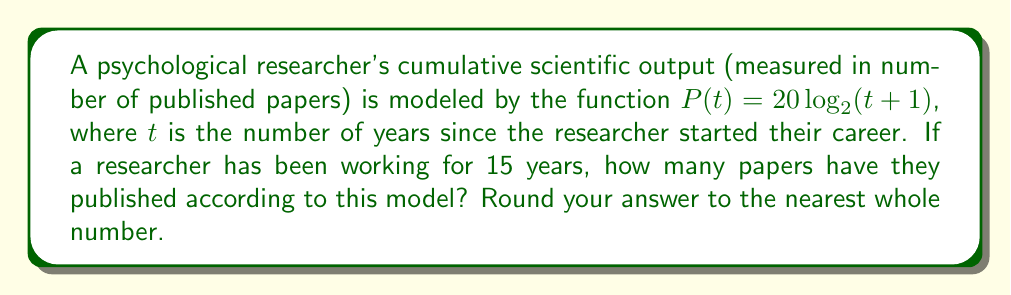Could you help me with this problem? To solve this problem, we need to follow these steps:

1. Identify the given information:
   - The function modeling the cumulative scientific output is $P(t) = 20 \log_2(t+1)$
   - The researcher has been working for 15 years, so $t = 15$

2. Substitute $t = 15$ into the function:
   $P(15) = 20 \log_2(15+1)$

3. Simplify the expression inside the logarithm:
   $P(15) = 20 \log_2(16)$

4. Evaluate the logarithm:
   $\log_2(16) = 4$ (since $2^4 = 16$)

5. Multiply the result by 20:
   $P(15) = 20 \cdot 4 = 80$

6. Round to the nearest whole number:
   80 is already a whole number, so no rounding is necessary.

Therefore, according to this model, the researcher has published 80 papers after 15 years of work.
Answer: 80 papers 